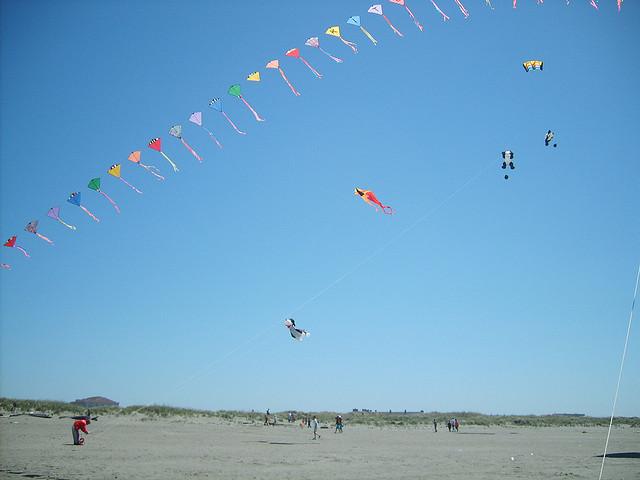How many kites resemble fish?
Keep it brief. 1. What is in the sky?
Answer briefly. Kites. How many kites are yellow?
Quick response, please. 4. 